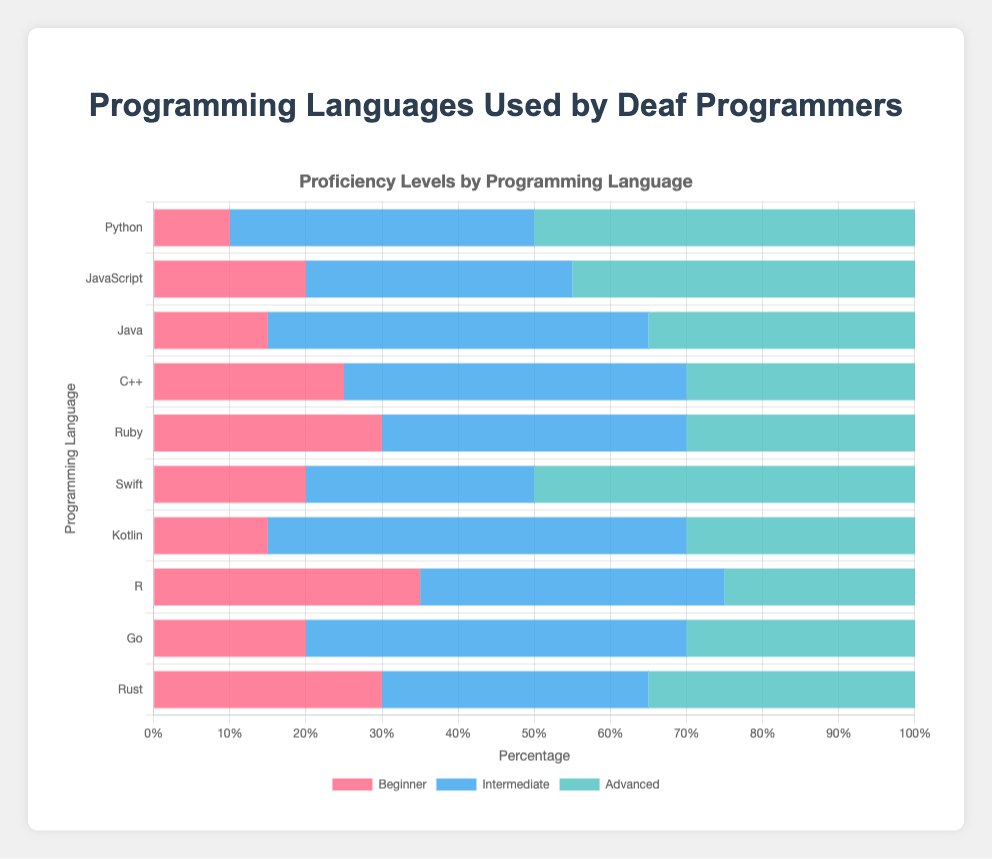Which programming language has the highest number of advanced users? By looking at the lengths of the bars labeled "Advanced" for each programming language, it's clear that Python has the highest bar with 50 advanced users.
Answer: Python How many total users for JavaScript are there across all proficiency levels? To find the total number of JavaScript users, sum the Beginner, Intermediate, and Advanced values: 20 + 35 + 45 = 100.
Answer: 100 Which programming language has the smallest number of beginner users? By comparing the heights of the "Beginner" bars, Python has the smallest bar with only 10 beginner users.
Answer: Python Is the number of intermediate Kotlin users greater than intermediate Python users? The bar for Intermediate Kotlin users is longer than that for Python; Kotlin has 55 intermediate users while Python has 40.
Answer: Yes If you combine the advanced users of C++ and Ruby, how do they compare to the advanced users of Swift? Adding the advanced users of C++ (30) and Ruby (30) gives 60. This is greater than Swift's 50 advanced users.
Answer: C++ and Ruby combined have more advanced users than Swift What is the average number of total users per programming language? First, find the total users for each language: Python (100), JavaScript (100), Java (100), C++ (100), Ruby (100), Swift (100), Kotlin (100), R (100), Go (100), Rust (100). Sum these totals, 100*10 = 1000. Then divide by the number of languages: 1000 / 10 = 100.
Answer: 100 Which programming language has equal numbers of beginner and advanced users? By checking the data, Rust has 30 beginner users and 35 advanced users, which are equal in value.
Answer: Rust What is the most common proficiency level across all programming languages? Summing up all Beginner, Intermediate, and Advanced values, we get: Beginner (220), Intermediate (420), Advanced (360). Intermediate has the highest count.
Answer: Intermediate users For Python, what is the percentage distribution of each proficiency level? Python has 10 beginner, 40 intermediate, and 50 advanced users, totaling 100 users. Percentages are: Beginner 10%, Intermediate 40%, Advanced 50%.
Answer: Beginner 10%, Intermediate 40%, Advanced 50% Are there more advanced Python users than combined advanced users of JavaScript and Rust? Python has 50 advanced users. JavaScript and Rust combined have 45 + 35 = 80 advanced users, which is greater than Python's.
Answer: No 